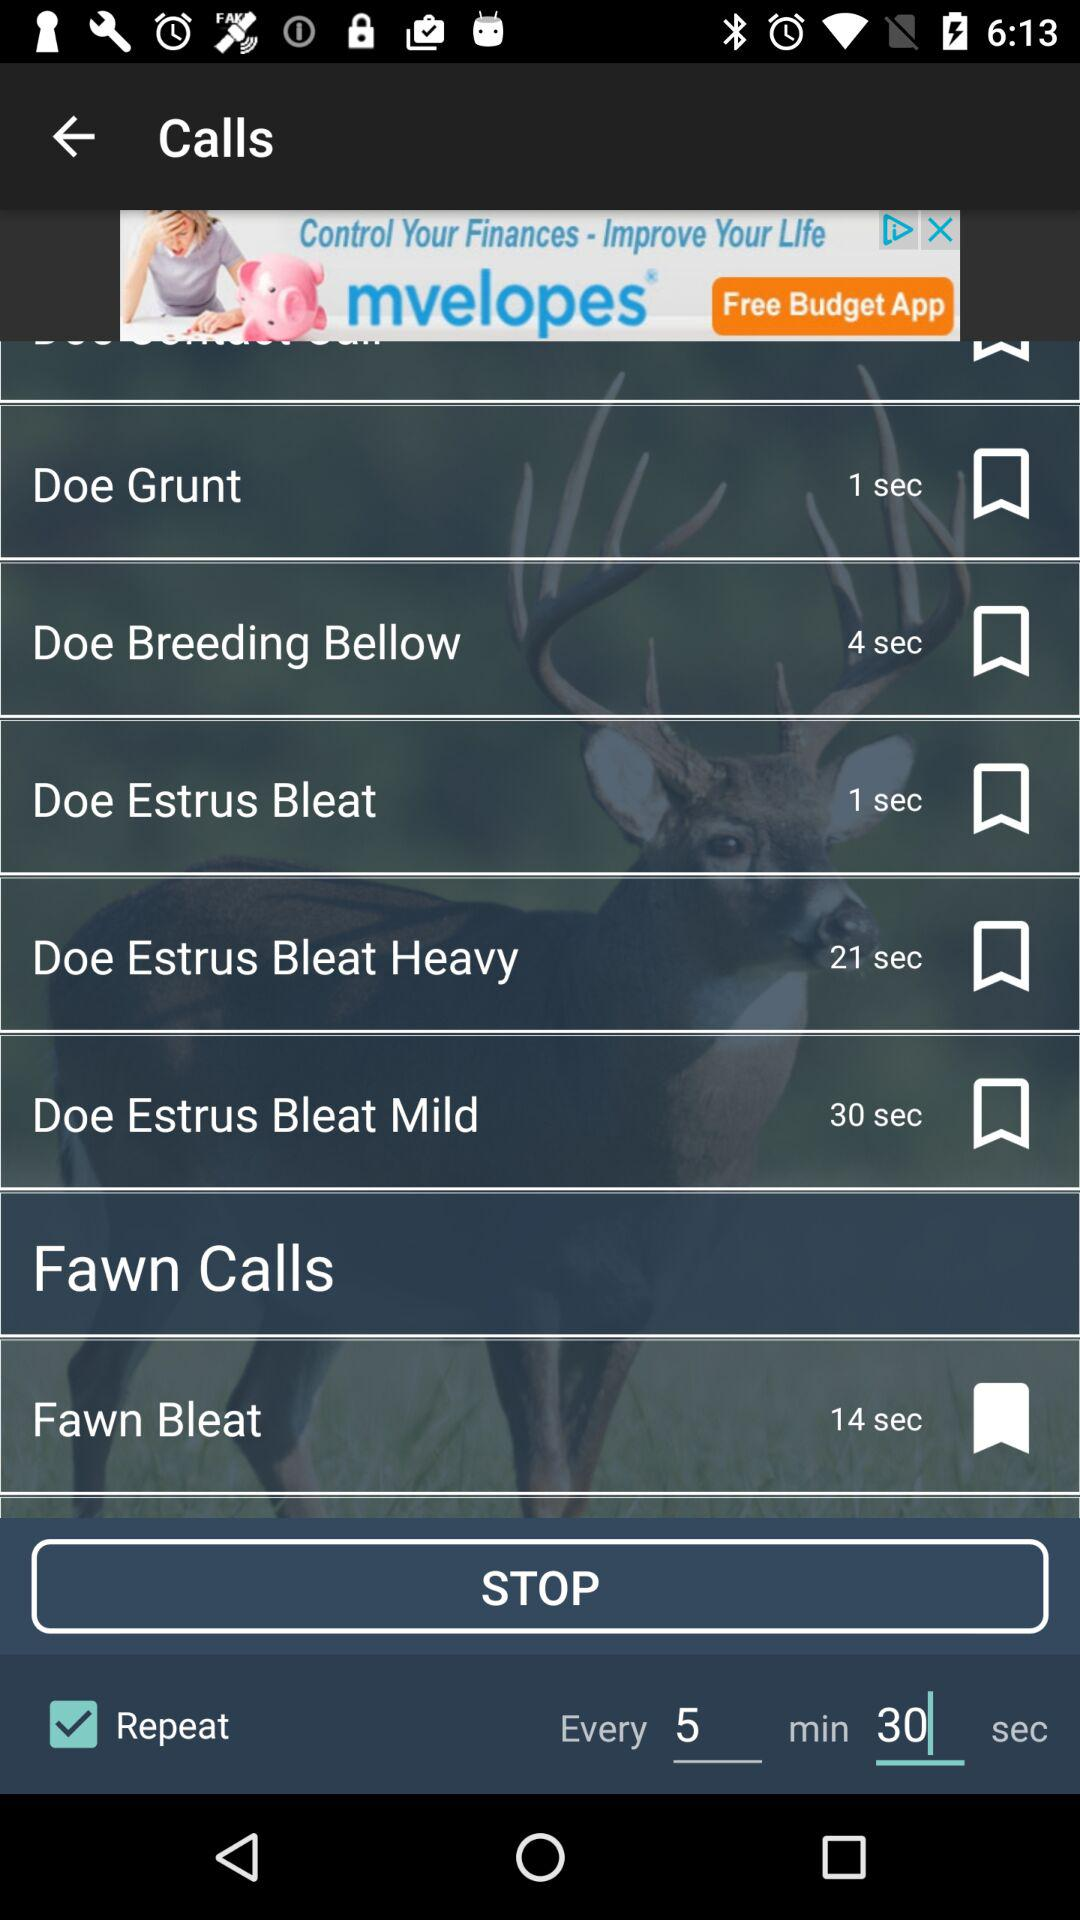What is the name of the call which is set as a bookmark? The name of the call is "Fawn Bleat". 